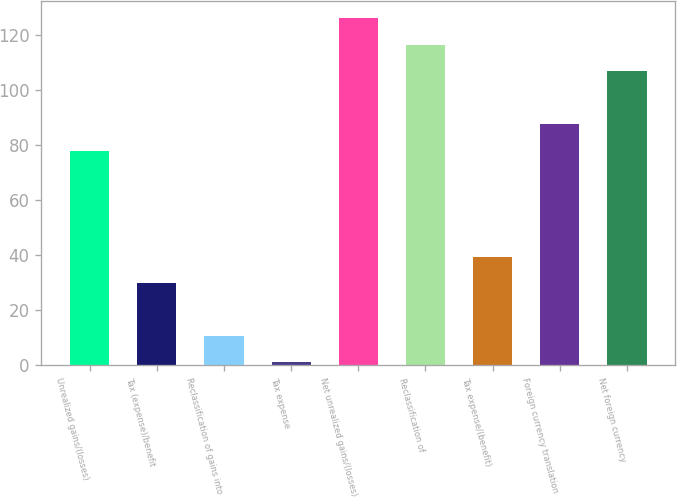<chart> <loc_0><loc_0><loc_500><loc_500><bar_chart><fcel>Unrealized gains/(losses)<fcel>Tax (expense)/benefit<fcel>Reclassification of gains into<fcel>Tax expense<fcel>Net unrealized gains/(losses)<fcel>Reclassification of<fcel>Tax expense/(benefit)<fcel>Foreign currency translation<fcel>Net foreign currency<nl><fcel>78.04<fcel>29.89<fcel>10.63<fcel>1<fcel>126.19<fcel>116.56<fcel>39.52<fcel>87.67<fcel>106.93<nl></chart> 